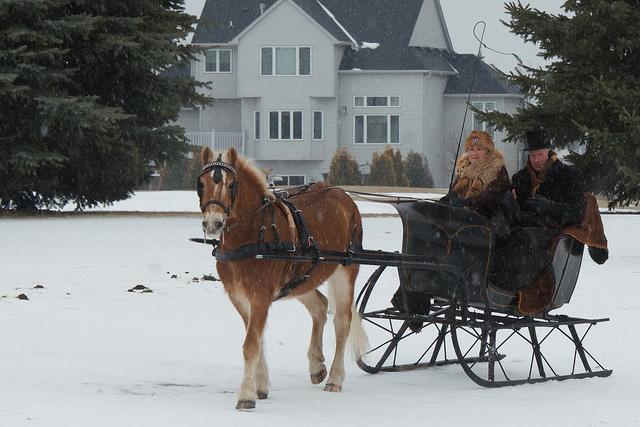How many people is in the sled?
Write a very short answer. 2. What type of event are they participating in?
Give a very brief answer. Sledding. What is in the cart being pulled by the horse and pony?
Keep it brief. People. Is it wintertime weather or summer weather?
Quick response, please. Winter. What is the horse and pony pulling?
Write a very short answer. Sled. Is the horse moving?
Quick response, please. Yes. 